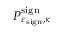Convert formula to latex. <formula><loc_0><loc_0><loc_500><loc_500>P _ { \varepsilon _ { s i g n } , \kappa } ^ { s i g n }</formula> 